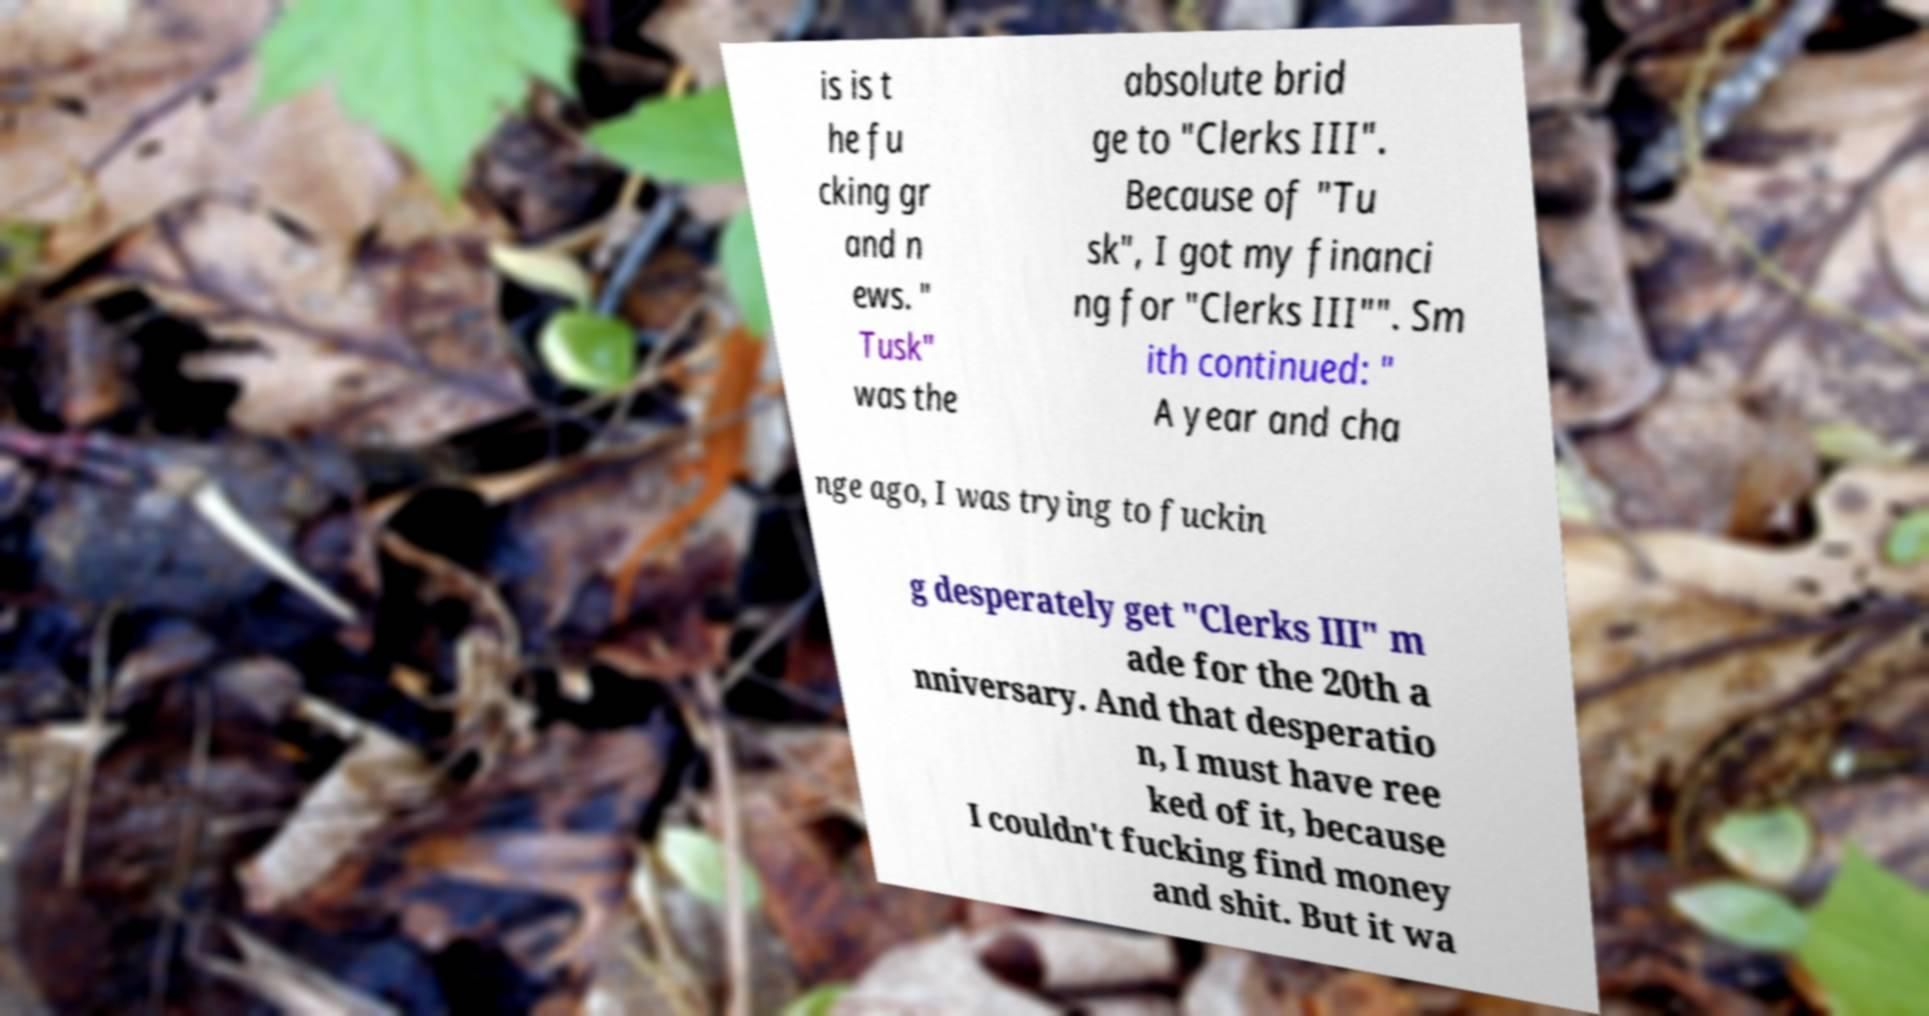Please identify and transcribe the text found in this image. is is t he fu cking gr and n ews. " Tusk" was the absolute brid ge to "Clerks III". Because of "Tu sk", I got my financi ng for "Clerks III"". Sm ith continued: " A year and cha nge ago, I was trying to fuckin g desperately get "Clerks III" m ade for the 20th a nniversary. And that desperatio n, I must have ree ked of it, because I couldn't fucking find money and shit. But it wa 